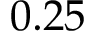Convert formula to latex. <formula><loc_0><loc_0><loc_500><loc_500>0 . 2 5</formula> 